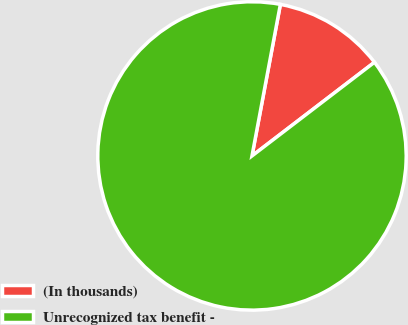Convert chart to OTSL. <chart><loc_0><loc_0><loc_500><loc_500><pie_chart><fcel>(In thousands)<fcel>Unrecognized tax benefit -<nl><fcel>11.66%<fcel>88.34%<nl></chart> 